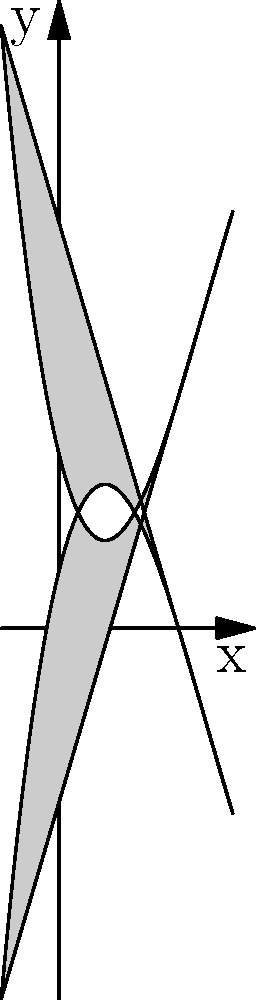As a creative mentor introducing new artistic styles to a graphic novelist, you've created a unique character silhouette using polynomial functions. The silhouette is formed by the area between two cubic polynomials: $f(x) = 0.1x^3 - 1.5x^2 + 4x + 2$ and $g(x) = -0.1x^3 + 1.5x^2 - 4x + 6$. What is the maximum width of the character silhouette, and at which x-coordinate does it occur? To find the maximum width of the character silhouette, we need to follow these steps:

1. The width of the silhouette at any point is the vertical distance between the two functions: $g(x) - f(x)$.

2. Let's define a new function $h(x) = g(x) - f(x)$:
   $h(x) = (-0.1x^3 + 1.5x^2 - 4x + 6) - (0.1x^3 - 1.5x^2 + 4x + 2)$
   $h(x) = -0.2x^3 + 3x^2 - 8x + 4$

3. To find the maximum of $h(x)$, we need to find where its derivative equals zero:
   $h'(x) = -0.6x^2 + 6x - 8$

4. Set $h'(x) = 0$ and solve:
   $-0.6x^2 + 6x - 8 = 0$
   $3x^2 - 30x + 40 = 0$

5. This is a quadratic equation. We can solve it using the quadratic formula:
   $x = \frac{-b \pm \sqrt{b^2 - 4ac}}{2a}$

   Where $a = 3$, $b = -30$, and $c = 40$

6. Solving this gives us:
   $x = \frac{30 \pm \sqrt{900 - 480}}{6} = \frac{30 \pm \sqrt{420}}{6}$

7. The positive solution is approximately 8.41, but this is outside our domain.
   The negative solution is approximately 1.59, which is within our domain.

8. Therefore, the maximum width occurs at $x \approx 1.59$.

9. To find the maximum width, we calculate $h(1.59)$:
   $h(1.59) \approx -0.2(1.59)^3 + 3(1.59)^2 - 8(1.59) + 4 \approx 4$

Thus, the maximum width is approximately 4 units and occurs at $x \approx 1.59$.
Answer: Maximum width: 4 units; x-coordinate: 1.59 